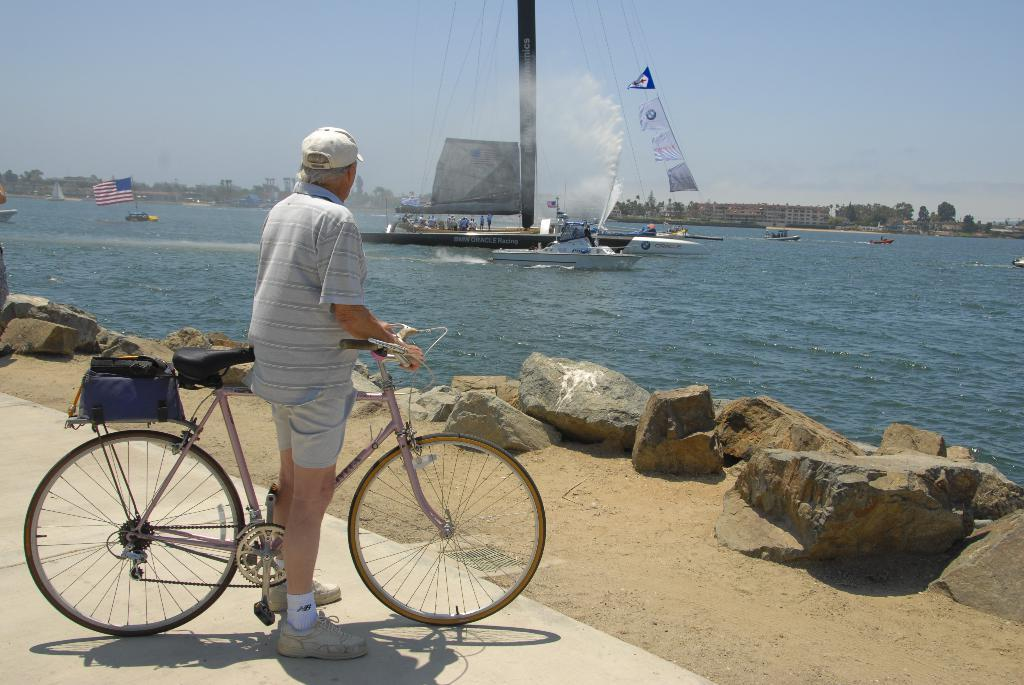Who is the main subject in the image? There is an old man in the image. What is the old man holding in the image? The old man is holding a bicycle. What type of clothing is the old man wearing? The old man is wearing a short and shirt. What is in front of the old man? There are stones in front of the old man. What can be seen in the background of the image? There is a sea in the image, and there is a boat in the sea. What type of competition is the old man participating in with his pet in the image? There is no pet present in the image, and the old man is not participating in any competition. 